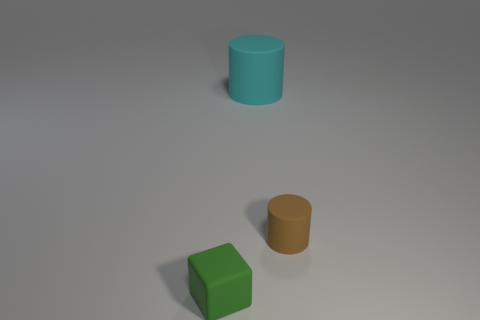How many small matte cylinders are there?
Provide a short and direct response. 1. What color is the tiny thing that is in front of the brown matte cylinder?
Make the answer very short. Green. What size is the cyan thing?
Your answer should be very brief. Large. There is a small matte thing on the right side of the matte block that is in front of the tiny brown thing; what color is it?
Ensure brevity in your answer.  Brown. Is there any other thing that has the same size as the cyan thing?
Offer a terse response. No. Is the shape of the thing behind the small rubber cylinder the same as  the brown object?
Your answer should be very brief. Yes. How many matte things are right of the green cube and in front of the cyan rubber thing?
Offer a very short reply. 1. What color is the tiny object behind the thing in front of the tiny matte object behind the small green rubber object?
Your answer should be compact. Brown. What number of tiny green blocks are left of the rubber object behind the small cylinder?
Offer a terse response. 1. How many other things are the same shape as the green rubber object?
Make the answer very short. 0. 